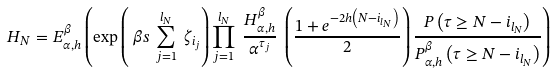Convert formula to latex. <formula><loc_0><loc_0><loc_500><loc_500>H _ { N } & = E _ { \alpha , h } ^ { \beta } \left ( \exp \left ( \ \beta s \ \sum _ { j = 1 } ^ { l _ { N } } \ \zeta _ { i _ { j } } \right ) \prod _ { j = 1 } ^ { l _ { N } } \ \frac { H _ { \alpha , h } ^ { \beta } } { \alpha ^ { \tau _ { j } } } \ \left ( \frac { 1 + e ^ { - 2 h \left ( N - i _ { l _ { N } } \right ) } } { 2 } \right ) \frac { P \left ( \tau \geq N - i _ { l _ { N } } \right ) } { P _ { \alpha , h } ^ { \beta } \left ( \tau \geq N - i _ { l _ { N } } \right ) } \right )</formula> 